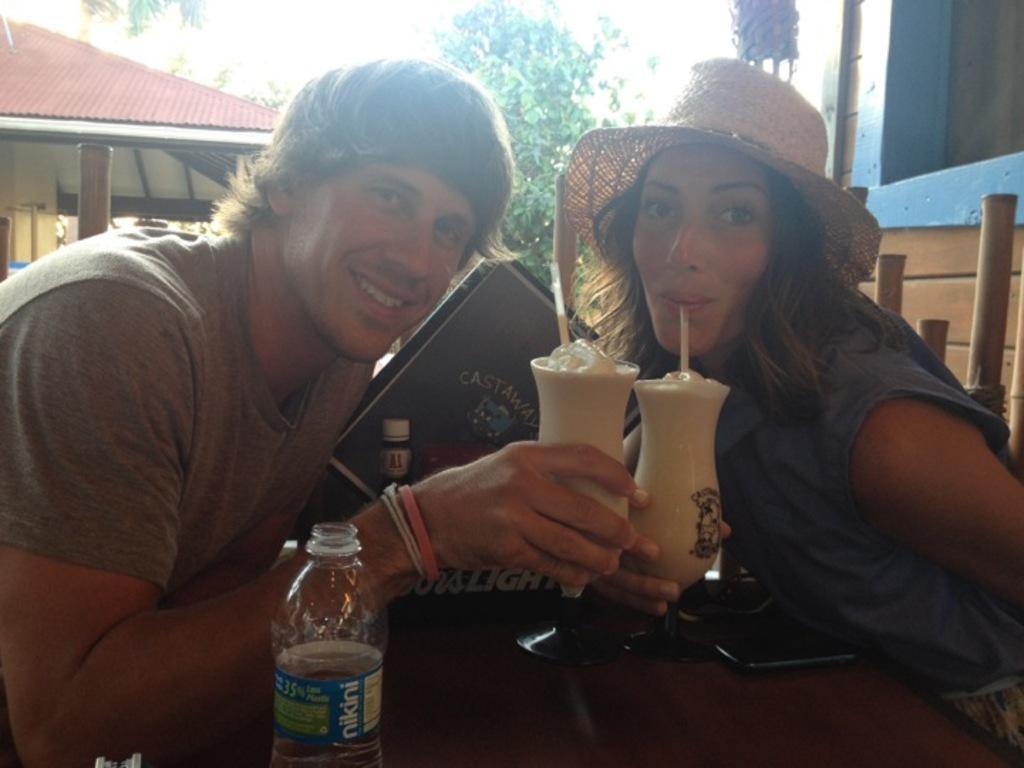Can you describe this image briefly? This is a picture of a two persons, one is a man and other is a women. The women is wearing a hat and the man is holding the juice. This is a table on top of the table there is a water bottle and the mobile. Background of the two people is a tree and the house. 